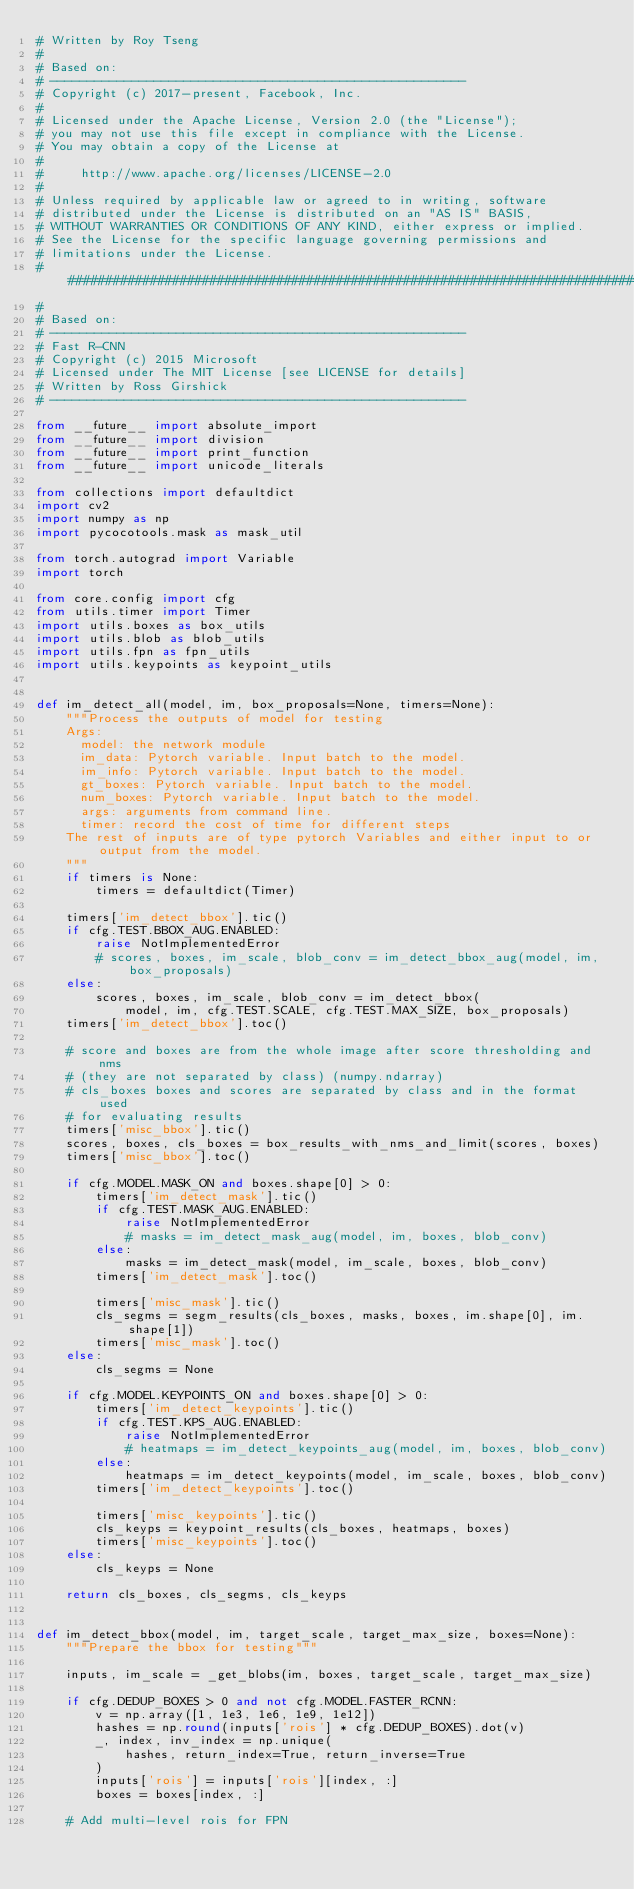Convert code to text. <code><loc_0><loc_0><loc_500><loc_500><_Python_># Written by Roy Tseng
#
# Based on:
# --------------------------------------------------------
# Copyright (c) 2017-present, Facebook, Inc.
#
# Licensed under the Apache License, Version 2.0 (the "License");
# you may not use this file except in compliance with the License.
# You may obtain a copy of the License at
#
#     http://www.apache.org/licenses/LICENSE-2.0
#
# Unless required by applicable law or agreed to in writing, software
# distributed under the License is distributed on an "AS IS" BASIS,
# WITHOUT WARRANTIES OR CONDITIONS OF ANY KIND, either express or implied.
# See the License for the specific language governing permissions and
# limitations under the License.
##############################################################################
#
# Based on:
# --------------------------------------------------------
# Fast R-CNN
# Copyright (c) 2015 Microsoft
# Licensed under The MIT License [see LICENSE for details]
# Written by Ross Girshick
# --------------------------------------------------------

from __future__ import absolute_import
from __future__ import division
from __future__ import print_function
from __future__ import unicode_literals

from collections import defaultdict
import cv2
import numpy as np
import pycocotools.mask as mask_util

from torch.autograd import Variable
import torch

from core.config import cfg
from utils.timer import Timer
import utils.boxes as box_utils
import utils.blob as blob_utils
import utils.fpn as fpn_utils
import utils.keypoints as keypoint_utils


def im_detect_all(model, im, box_proposals=None, timers=None):
    """Process the outputs of model for testing
    Args:
      model: the network module
      im_data: Pytorch variable. Input batch to the model.
      im_info: Pytorch variable. Input batch to the model.
      gt_boxes: Pytorch variable. Input batch to the model.
      num_boxes: Pytorch variable. Input batch to the model.
      args: arguments from command line.
      timer: record the cost of time for different steps
    The rest of inputs are of type pytorch Variables and either input to or output from the model.
    """
    if timers is None:
        timers = defaultdict(Timer)

    timers['im_detect_bbox'].tic()
    if cfg.TEST.BBOX_AUG.ENABLED:
        raise NotImplementedError
        # scores, boxes, im_scale, blob_conv = im_detect_bbox_aug(model, im, box_proposals)
    else:
        scores, boxes, im_scale, blob_conv = im_detect_bbox(
            model, im, cfg.TEST.SCALE, cfg.TEST.MAX_SIZE, box_proposals)
    timers['im_detect_bbox'].toc()

    # score and boxes are from the whole image after score thresholding and nms
    # (they are not separated by class) (numpy.ndarray)
    # cls_boxes boxes and scores are separated by class and in the format used
    # for evaluating results
    timers['misc_bbox'].tic()
    scores, boxes, cls_boxes = box_results_with_nms_and_limit(scores, boxes)
    timers['misc_bbox'].toc()

    if cfg.MODEL.MASK_ON and boxes.shape[0] > 0:
        timers['im_detect_mask'].tic()
        if cfg.TEST.MASK_AUG.ENABLED:
            raise NotImplementedError
            # masks = im_detect_mask_aug(model, im, boxes, blob_conv)
        else:
            masks = im_detect_mask(model, im_scale, boxes, blob_conv)
        timers['im_detect_mask'].toc()

        timers['misc_mask'].tic()
        cls_segms = segm_results(cls_boxes, masks, boxes, im.shape[0], im.shape[1])
        timers['misc_mask'].toc()
    else:
        cls_segms = None

    if cfg.MODEL.KEYPOINTS_ON and boxes.shape[0] > 0:
        timers['im_detect_keypoints'].tic()
        if cfg.TEST.KPS_AUG.ENABLED:
            raise NotImplementedError
            # heatmaps = im_detect_keypoints_aug(model, im, boxes, blob_conv)
        else:
            heatmaps = im_detect_keypoints(model, im_scale, boxes, blob_conv)
        timers['im_detect_keypoints'].toc()

        timers['misc_keypoints'].tic()
        cls_keyps = keypoint_results(cls_boxes, heatmaps, boxes)
        timers['misc_keypoints'].toc()
    else:
        cls_keyps = None

    return cls_boxes, cls_segms, cls_keyps


def im_detect_bbox(model, im, target_scale, target_max_size, boxes=None):
    """Prepare the bbox for testing"""

    inputs, im_scale = _get_blobs(im, boxes, target_scale, target_max_size)

    if cfg.DEDUP_BOXES > 0 and not cfg.MODEL.FASTER_RCNN:
        v = np.array([1, 1e3, 1e6, 1e9, 1e12])
        hashes = np.round(inputs['rois'] * cfg.DEDUP_BOXES).dot(v)
        _, index, inv_index = np.unique(
            hashes, return_index=True, return_inverse=True
        )
        inputs['rois'] = inputs['rois'][index, :]
        boxes = boxes[index, :]

    # Add multi-level rois for FPN</code> 